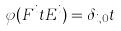Convert formula to latex. <formula><loc_0><loc_0><loc_500><loc_500>\varphi ( F ^ { i } t E ^ { i } ) = \delta _ { i , 0 } t</formula> 